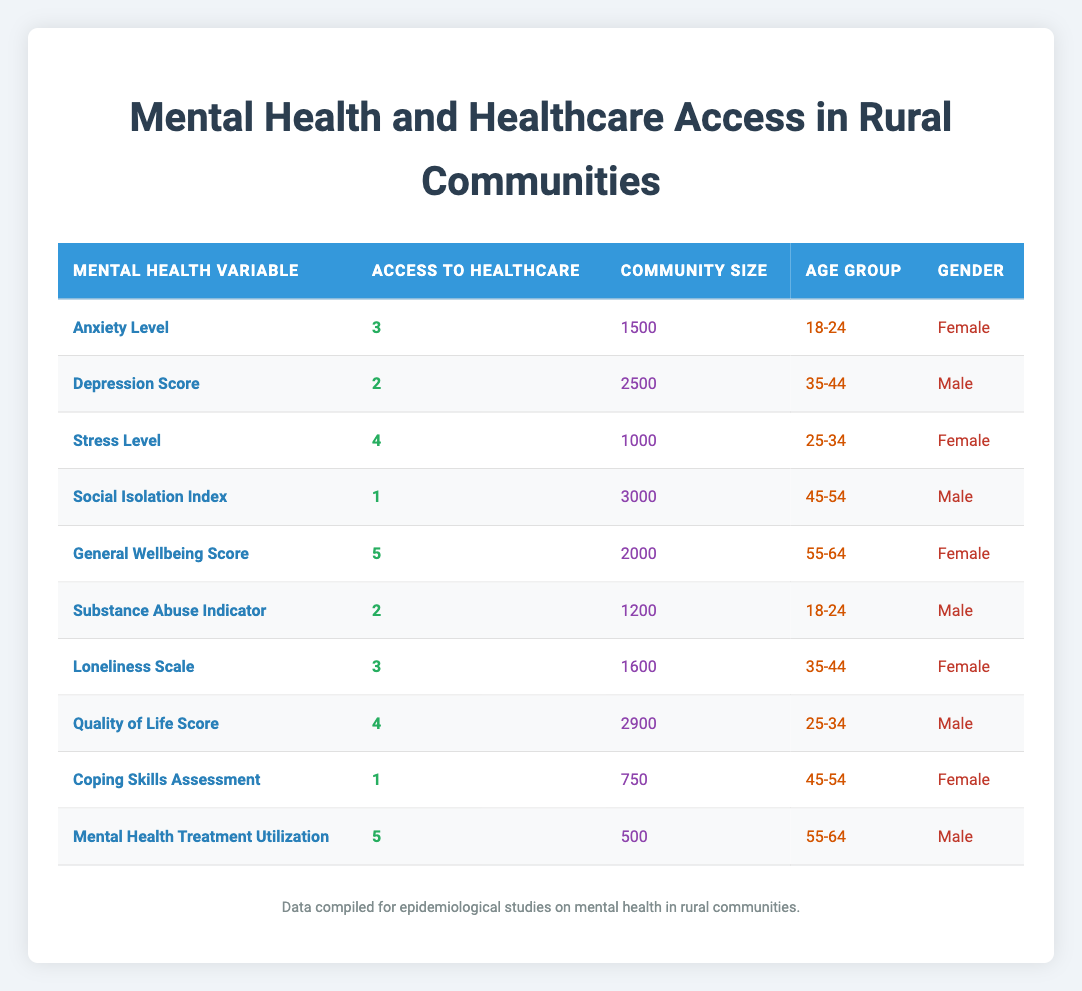What is the access to healthcare score for individuals with a high General Wellbeing Score? The General Wellbeing Score row in the table shows that access to healthcare is 5 for this mental health variable.
Answer: 5 What is the community size for the Mental Health Treatment Utilization? The Mental Health Treatment Utilization row indicates that the community size is 500.
Answer: 500 Are there more females or males in the reported data? There are five males (Depression Score, Substance Abuse Indicator, Quality of Life Score, Mental Health Treatment Utilization) and five females (Anxiety Level, Stress Level, General Wellbeing Score, Loneliness Scale, Coping Skills Assessment) in the table, indicating that the numbers are equal.
Answer: Equal What is the average access to healthcare score for individuals aged 18-24? There are two entries for the age group 18-24: Anxiety Level (3) and Substance Abuse Indicator (2). The average (3 + 2) / 2 = 2.5.
Answer: 2.5 What is the highest access to healthcare score from the female respondents? The access to healthcare score for both General Wellbeing Score (5) and Stress Level (4) should be examined. General Wellbeing Score has the highest score of 5.
Answer: 5 Is the average community size for the rows with access to healthcare score of 2 greater than the average community size for scores of 5? The community sizes for the access scores of 2 are 2500 (Depression Score) and 1200 (Substance Abuse Indicator), giving an average of (2500 + 1200) / 2 = 1850. The community sizes for scores of 5 are 2000 (General Wellbeing Score) and 500 (Mental Health Treatment Utilization), giving an average of (2000 + 500) / 2 = 1250. Since 1850 > 1250, the answer is yes.
Answer: Yes What is the difference in access to healthcare scores between the highest and lowest scores reported? The highest score is 5 (for General Wellbeing Score and Mental Health Treatment Utilization) and the lowest score is 1 (Social Isolation Index and Coping Skills Assessment). Therefore, the difference is 5 - 1 = 4.
Answer: 4 Which mental health variable has the lowest access to healthcare score? The Social Isolation Index and Coping Skills Assessment have the lowest access to healthcare score of 1, which can be seen directly in their respective rows.
Answer: Social Isolation Index and Coping Skills Assessment What is the sum of the access to healthcare scores for participants in the age group 35-44? The corresponding access scores for this age group are 2 from Depression Score and 3 from Loneliness Scale, giving a sum of 2 + 3 = 5.
Answer: 5 How many respondents reported a stress level of 4 or higher? The entries with scores of 4 or higher are Stress Level (4), General Wellbeing Score (5), and Mental Health Treatment Utilization (5), summing up to three respondents.
Answer: 3 